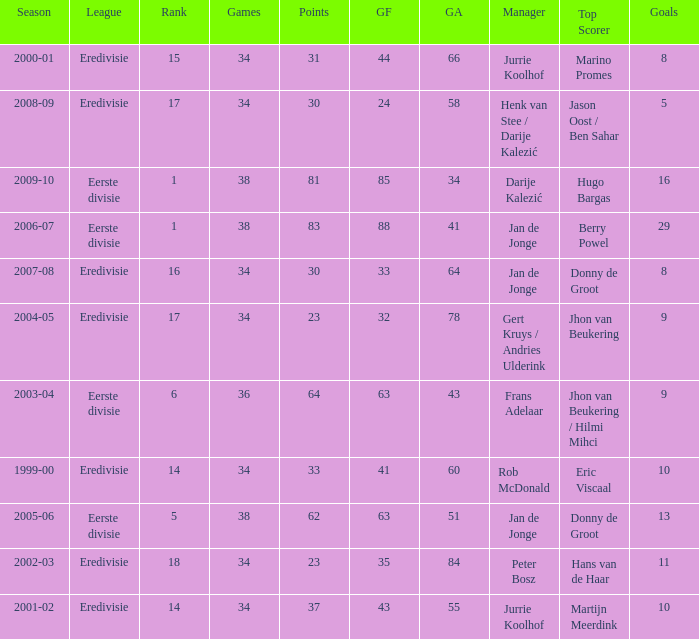How many seasons had a rank of 16? 1.0. 